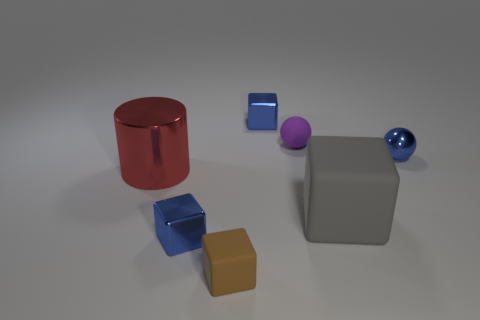Are there fewer metal spheres than tiny cyan metal spheres?
Offer a terse response. No. There is a purple matte object that is the same size as the brown thing; what is its shape?
Provide a succinct answer. Sphere. What number of other things are the same color as the big block?
Provide a short and direct response. 0. How many green rubber cylinders are there?
Your answer should be very brief. 0. What number of shiny objects are behind the tiny metal sphere and in front of the gray object?
Ensure brevity in your answer.  0. What material is the gray block?
Ensure brevity in your answer.  Rubber. Are any tiny metallic things visible?
Your response must be concise. Yes. What color is the rubber cube that is on the left side of the purple rubber sphere?
Keep it short and to the point. Brown. What number of large metallic things are to the left of the blue metallic object that is behind the small rubber thing that is behind the tiny blue metal ball?
Provide a short and direct response. 1. There is a blue object that is both on the left side of the small metallic ball and behind the big metallic cylinder; what is it made of?
Offer a very short reply. Metal. 